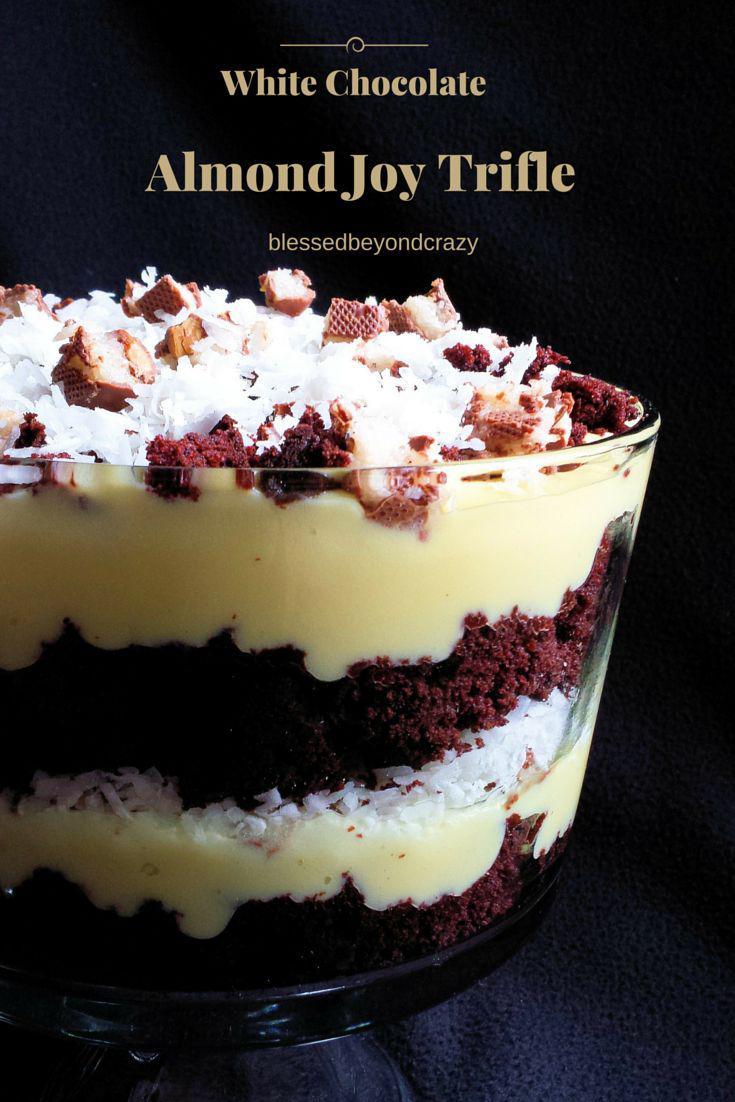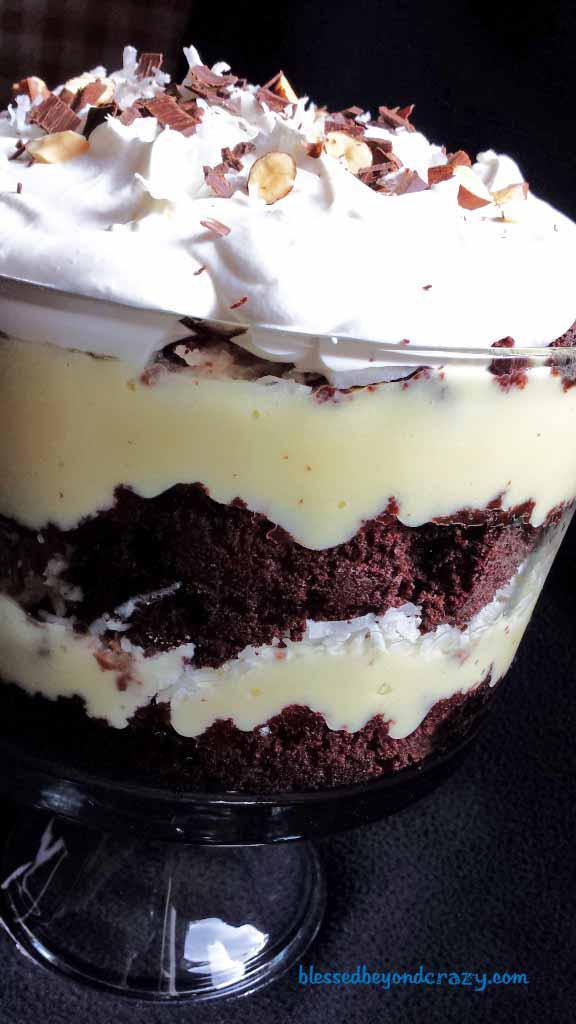The first image is the image on the left, the second image is the image on the right. Evaluate the accuracy of this statement regarding the images: "One image shows three servings of layered dessert that are not displayed in one horizontal row.". Is it true? Answer yes or no. No. The first image is the image on the left, the second image is the image on the right. Analyze the images presented: Is the assertion "Two large trifle desserts are made in clear bowls with alernating cake and creamy layers, ending with a garnished creamy top." valid? Answer yes or no. Yes. 